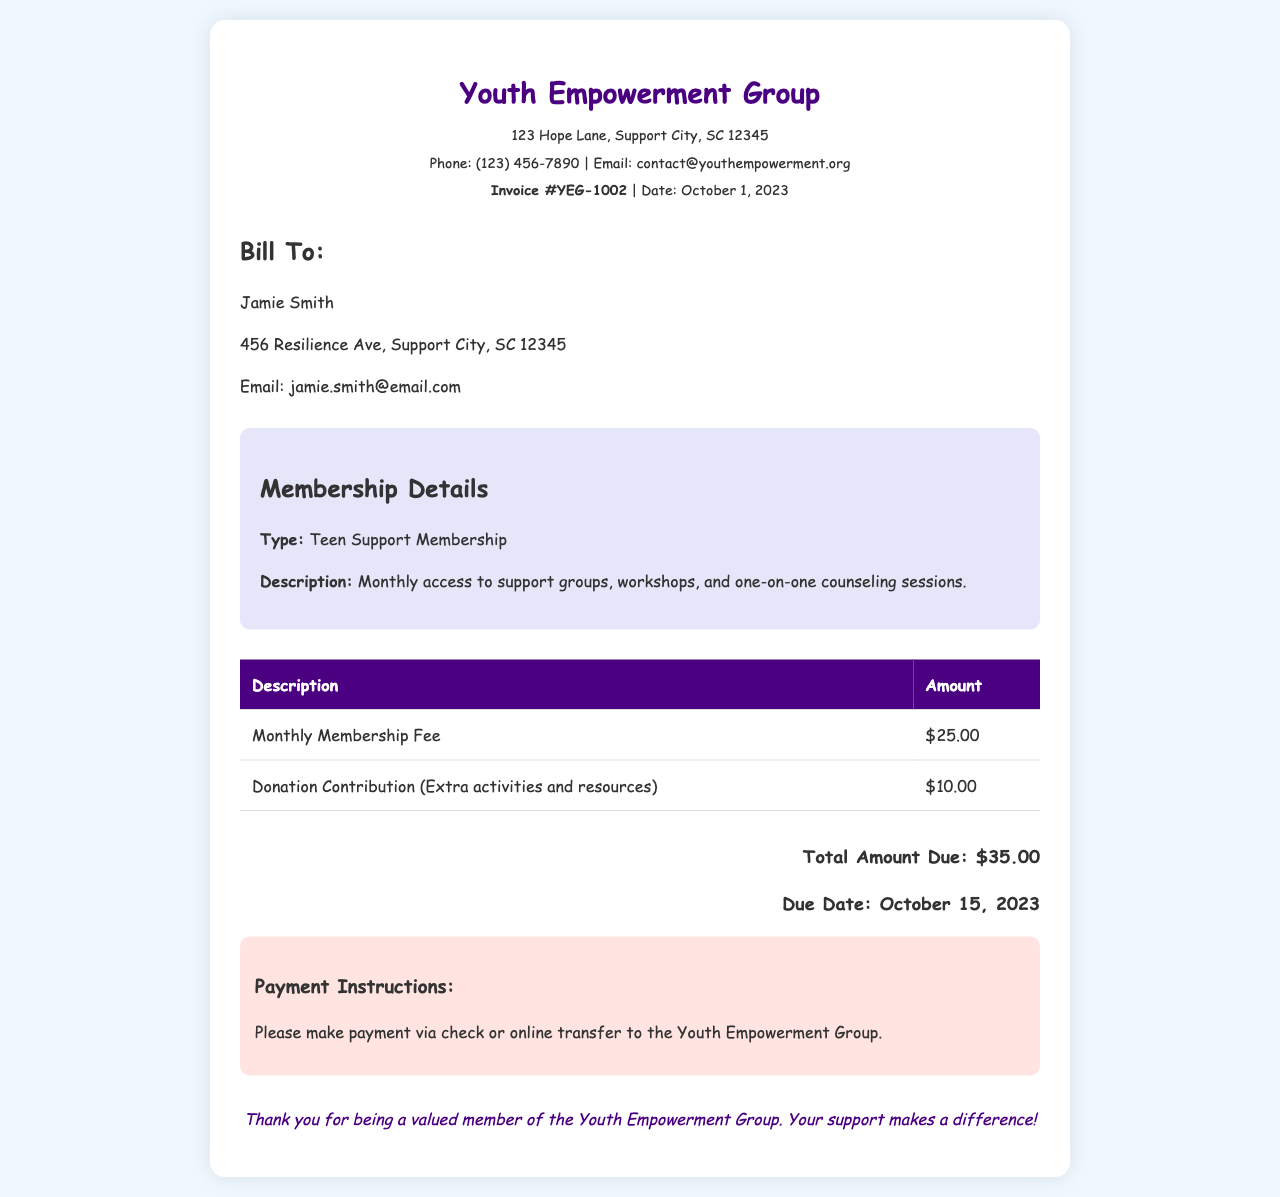what is the invoice number? The invoice number is found in the header of the document.
Answer: YEG-1002 who is the bill to? The information about the recipient can be found in the "Bill To" section of the document.
Answer: Jamie Smith what is the total amount due? The total amount due is stated at the bottom of the invoice.
Answer: $35.00 what is the due date? The due date is mentioned in the total section of the invoice.
Answer: October 15, 2023 how much is the monthly membership fee? The monthly membership fee is listed in the table of amounts.
Answer: $25.00 what type of membership is this invoice for? The type of membership is described in the membership details section.
Answer: Teen Support Membership what does the donation contribution support? The purpose of the donation contribution is mentioned alongside its value in the table.
Answer: Extra activities and resources what are the payment options? The payment instructions section describes the ways to make the payment.
Answer: Check or online transfer 